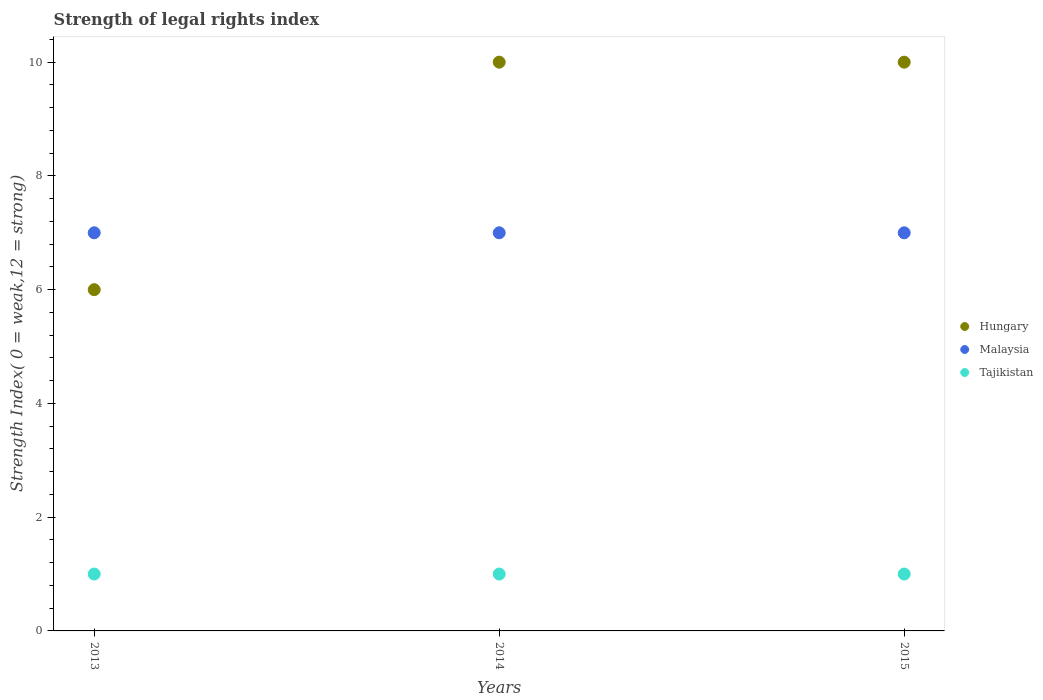Is the number of dotlines equal to the number of legend labels?
Keep it short and to the point. Yes. What is the strength index in Tajikistan in 2013?
Provide a short and direct response. 1. Across all years, what is the maximum strength index in Hungary?
Ensure brevity in your answer.  10. Across all years, what is the minimum strength index in Hungary?
Give a very brief answer. 6. What is the total strength index in Tajikistan in the graph?
Provide a succinct answer. 3. What is the difference between the strength index in Malaysia in 2015 and the strength index in Tajikistan in 2014?
Make the answer very short. 6. What is the average strength index in Tajikistan per year?
Provide a succinct answer. 1. In the year 2013, what is the difference between the strength index in Tajikistan and strength index in Malaysia?
Your answer should be very brief. -6. Is the strength index in Tajikistan in 2013 less than that in 2015?
Your answer should be compact. No. What is the difference between the highest and the second highest strength index in Tajikistan?
Provide a short and direct response. 0. What is the difference between the highest and the lowest strength index in Tajikistan?
Provide a short and direct response. 0. In how many years, is the strength index in Tajikistan greater than the average strength index in Tajikistan taken over all years?
Your answer should be very brief. 0. Is the sum of the strength index in Malaysia in 2013 and 2015 greater than the maximum strength index in Tajikistan across all years?
Your answer should be very brief. Yes. Is the strength index in Hungary strictly greater than the strength index in Tajikistan over the years?
Your answer should be compact. Yes. Is the strength index in Malaysia strictly less than the strength index in Hungary over the years?
Your answer should be compact. No. How many dotlines are there?
Make the answer very short. 3. What is the difference between two consecutive major ticks on the Y-axis?
Keep it short and to the point. 2. How many legend labels are there?
Provide a succinct answer. 3. What is the title of the graph?
Keep it short and to the point. Strength of legal rights index. What is the label or title of the Y-axis?
Make the answer very short. Strength Index( 0 = weak,12 = strong). What is the Strength Index( 0 = weak,12 = strong) in Malaysia in 2013?
Your answer should be compact. 7. What is the Strength Index( 0 = weak,12 = strong) in Tajikistan in 2013?
Your answer should be compact. 1. What is the Strength Index( 0 = weak,12 = strong) of Malaysia in 2014?
Keep it short and to the point. 7. What is the Strength Index( 0 = weak,12 = strong) in Hungary in 2015?
Ensure brevity in your answer.  10. What is the Strength Index( 0 = weak,12 = strong) of Malaysia in 2015?
Offer a very short reply. 7. Across all years, what is the maximum Strength Index( 0 = weak,12 = strong) of Tajikistan?
Keep it short and to the point. 1. Across all years, what is the minimum Strength Index( 0 = weak,12 = strong) of Hungary?
Make the answer very short. 6. What is the total Strength Index( 0 = weak,12 = strong) of Tajikistan in the graph?
Ensure brevity in your answer.  3. What is the difference between the Strength Index( 0 = weak,12 = strong) of Malaysia in 2013 and that in 2014?
Your answer should be compact. 0. What is the difference between the Strength Index( 0 = weak,12 = strong) of Malaysia in 2013 and that in 2015?
Offer a very short reply. 0. What is the difference between the Strength Index( 0 = weak,12 = strong) in Tajikistan in 2013 and that in 2015?
Give a very brief answer. 0. What is the difference between the Strength Index( 0 = weak,12 = strong) in Hungary in 2014 and that in 2015?
Your answer should be very brief. 0. What is the difference between the Strength Index( 0 = weak,12 = strong) of Malaysia in 2014 and that in 2015?
Provide a succinct answer. 0. What is the difference between the Strength Index( 0 = weak,12 = strong) of Tajikistan in 2014 and that in 2015?
Offer a very short reply. 0. What is the difference between the Strength Index( 0 = weak,12 = strong) in Hungary in 2013 and the Strength Index( 0 = weak,12 = strong) in Tajikistan in 2014?
Your response must be concise. 5. What is the difference between the Strength Index( 0 = weak,12 = strong) of Hungary in 2013 and the Strength Index( 0 = weak,12 = strong) of Malaysia in 2015?
Your answer should be compact. -1. What is the difference between the Strength Index( 0 = weak,12 = strong) of Hungary in 2013 and the Strength Index( 0 = weak,12 = strong) of Tajikistan in 2015?
Your answer should be very brief. 5. What is the difference between the Strength Index( 0 = weak,12 = strong) in Malaysia in 2013 and the Strength Index( 0 = weak,12 = strong) in Tajikistan in 2015?
Your response must be concise. 6. What is the difference between the Strength Index( 0 = weak,12 = strong) of Hungary in 2014 and the Strength Index( 0 = weak,12 = strong) of Malaysia in 2015?
Give a very brief answer. 3. What is the difference between the Strength Index( 0 = weak,12 = strong) in Hungary in 2014 and the Strength Index( 0 = weak,12 = strong) in Tajikistan in 2015?
Provide a short and direct response. 9. What is the difference between the Strength Index( 0 = weak,12 = strong) in Malaysia in 2014 and the Strength Index( 0 = weak,12 = strong) in Tajikistan in 2015?
Your answer should be compact. 6. What is the average Strength Index( 0 = weak,12 = strong) of Hungary per year?
Keep it short and to the point. 8.67. What is the average Strength Index( 0 = weak,12 = strong) in Malaysia per year?
Make the answer very short. 7. In the year 2014, what is the difference between the Strength Index( 0 = weak,12 = strong) in Malaysia and Strength Index( 0 = weak,12 = strong) in Tajikistan?
Ensure brevity in your answer.  6. In the year 2015, what is the difference between the Strength Index( 0 = weak,12 = strong) in Hungary and Strength Index( 0 = weak,12 = strong) in Malaysia?
Offer a terse response. 3. What is the ratio of the Strength Index( 0 = weak,12 = strong) in Malaysia in 2013 to that in 2015?
Your answer should be very brief. 1. What is the ratio of the Strength Index( 0 = weak,12 = strong) of Tajikistan in 2013 to that in 2015?
Offer a terse response. 1. What is the difference between the highest and the second highest Strength Index( 0 = weak,12 = strong) of Hungary?
Keep it short and to the point. 0. What is the difference between the highest and the second highest Strength Index( 0 = weak,12 = strong) of Malaysia?
Your answer should be compact. 0. 